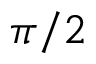Convert formula to latex. <formula><loc_0><loc_0><loc_500><loc_500>\pi / 2</formula> 